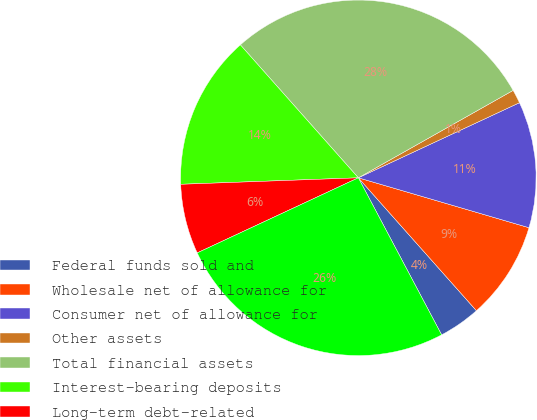Convert chart. <chart><loc_0><loc_0><loc_500><loc_500><pie_chart><fcel>Federal funds sold and<fcel>Wholesale net of allowance for<fcel>Consumer net of allowance for<fcel>Other assets<fcel>Total financial assets<fcel>Interest-bearing deposits<fcel>Long-term debt-related<fcel>Total financial liabilities<nl><fcel>3.8%<fcel>8.91%<fcel>11.47%<fcel>1.24%<fcel>28.37%<fcel>14.03%<fcel>6.36%<fcel>25.82%<nl></chart> 